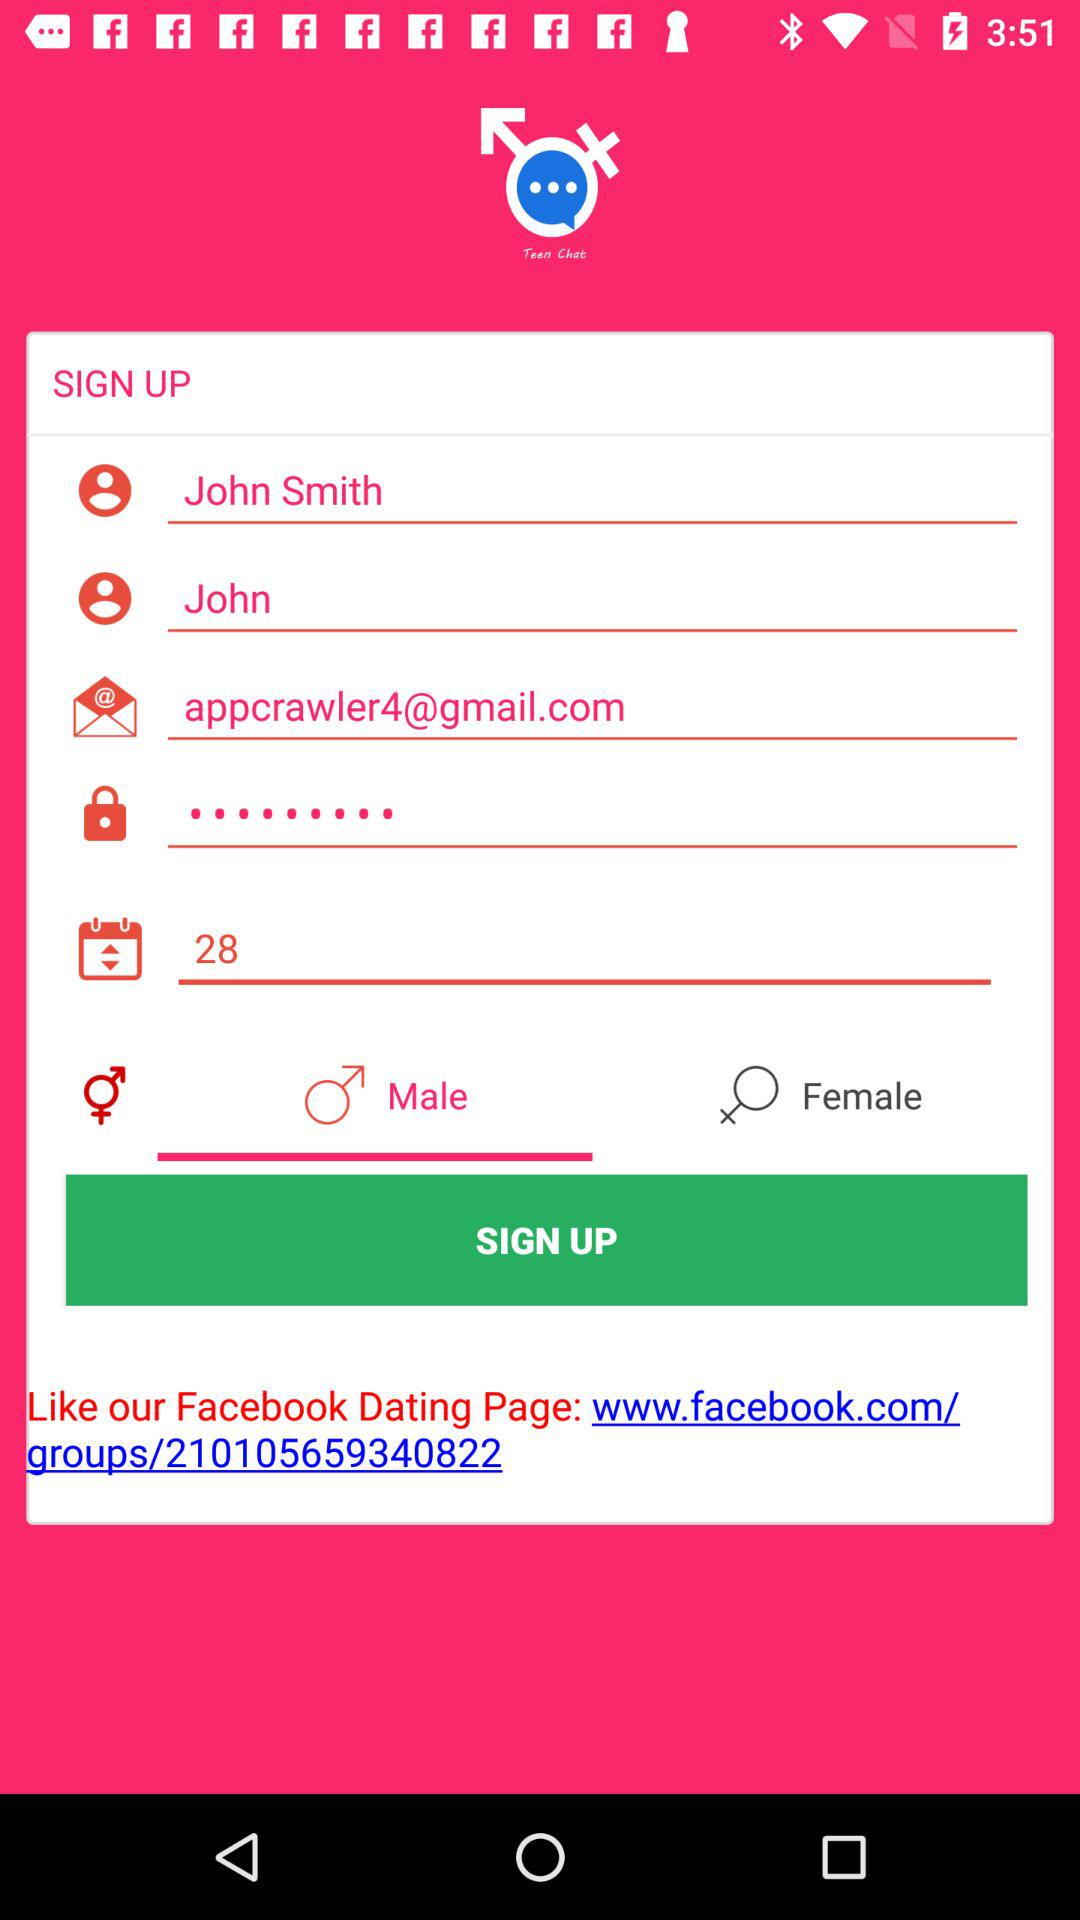What is the selected gender? The selected gender is male. 